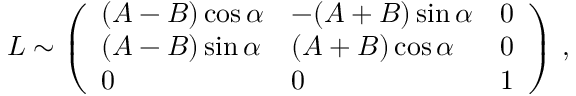<formula> <loc_0><loc_0><loc_500><loc_500>L \sim \left ( \begin{array} { l l l } { ( A - B ) \cos \alpha } & { - ( A + B ) \sin \alpha } & { 0 } \\ { ( A - B ) \sin \alpha } & { ( A + B ) \cos \alpha } & { 0 } \\ { 0 } & { 0 } & { 1 } \end{array} \right ) \, ,</formula> 